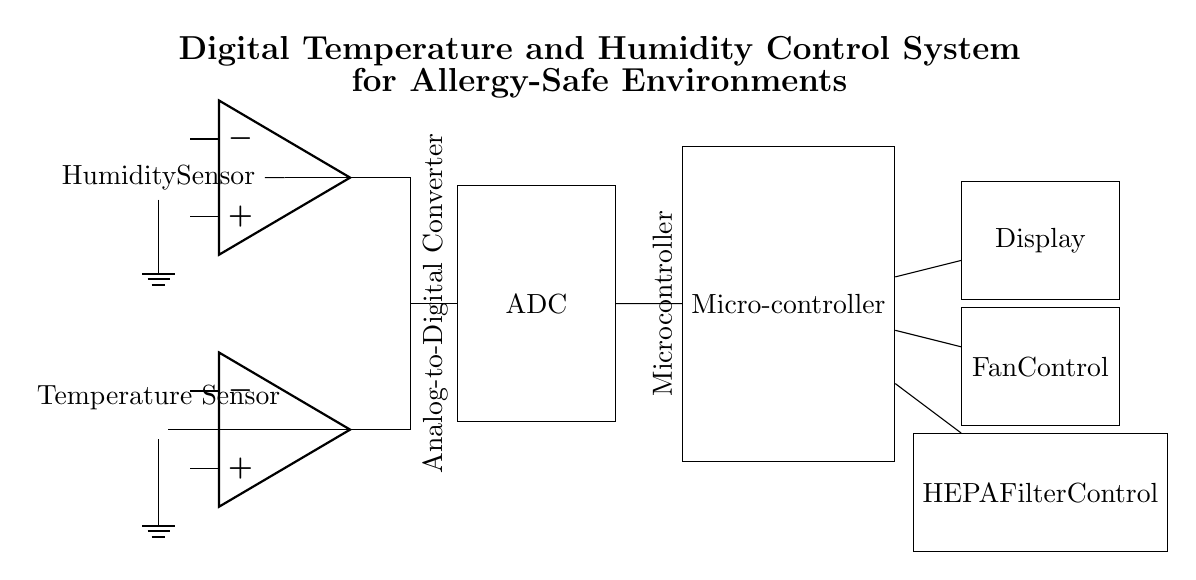What is the main purpose of this circuit? The main purpose of this circuit is to control temperature and humidity levels in environments to ensure they are safe for allergy sufferers. This is deduced from the title and components that measure and control environmental conditions.
Answer: Control temperature and humidity How many sensors are present in this circuit? There are two sensors in this circuit: a temperature sensor and a humidity sensor. This is directly observable from the labeled components present in the diagram.
Answer: Two sensors What component is used to convert analog signals to digital? The component responsible for converting analog signals to digital is the Analog-to-Digital Converter (ADC). This is clearly labeled in the circuit diagram as connecting both sensors to the microcontroller.
Answer: ADC What is the function of the microcontroller in this circuit? The microcontroller in this circuit processes the data from the temperature and humidity sensors and drives the control components like the fan and HEPA filter. This is indicated by its connections to the ADC and the control units.
Answer: Data processing and control Which component controls the HEPA filter in this circuit? The component that controls the HEPA filter is labeled as "HEPA Filter Control". It receives commands from the microcontroller based on the data processed from the sensors.
Answer: HEPA Filter Control What is the output of the microcontroller used for? The outputs of the microcontroller are used to manage the fan and HEPA filter control, which are essential for maintaining the desired air quality. This is determined from the connections made from the microcontroller to both components.
Answer: Fan and HEPA control What type of sensors are used in this circuit? The types of sensors used in this circuit are a thermistor for temperature and a generic humidity sensor. This is based on the labels provided for each sensor in the diagram.
Answer: Thermistor and humidity sensor 